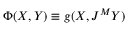<formula> <loc_0><loc_0><loc_500><loc_500>\Phi ( X , Y ) \equiv g ( X , J ^ { M } Y )</formula> 